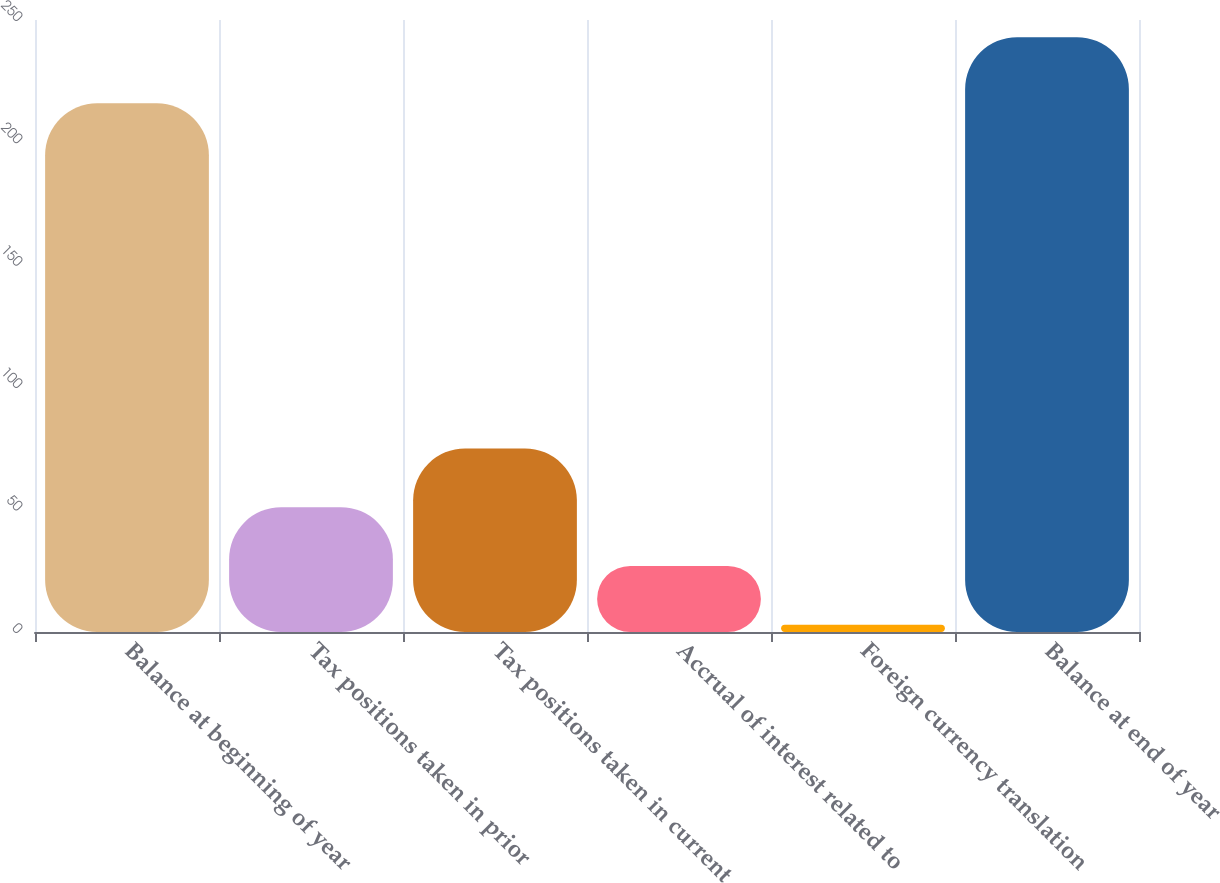Convert chart to OTSL. <chart><loc_0><loc_0><loc_500><loc_500><bar_chart><fcel>Balance at beginning of year<fcel>Tax positions taken in prior<fcel>Tax positions taken in current<fcel>Accrual of interest related to<fcel>Foreign currency translation<fcel>Balance at end of year<nl><fcel>216<fcel>51<fcel>75<fcel>27<fcel>3<fcel>243<nl></chart> 